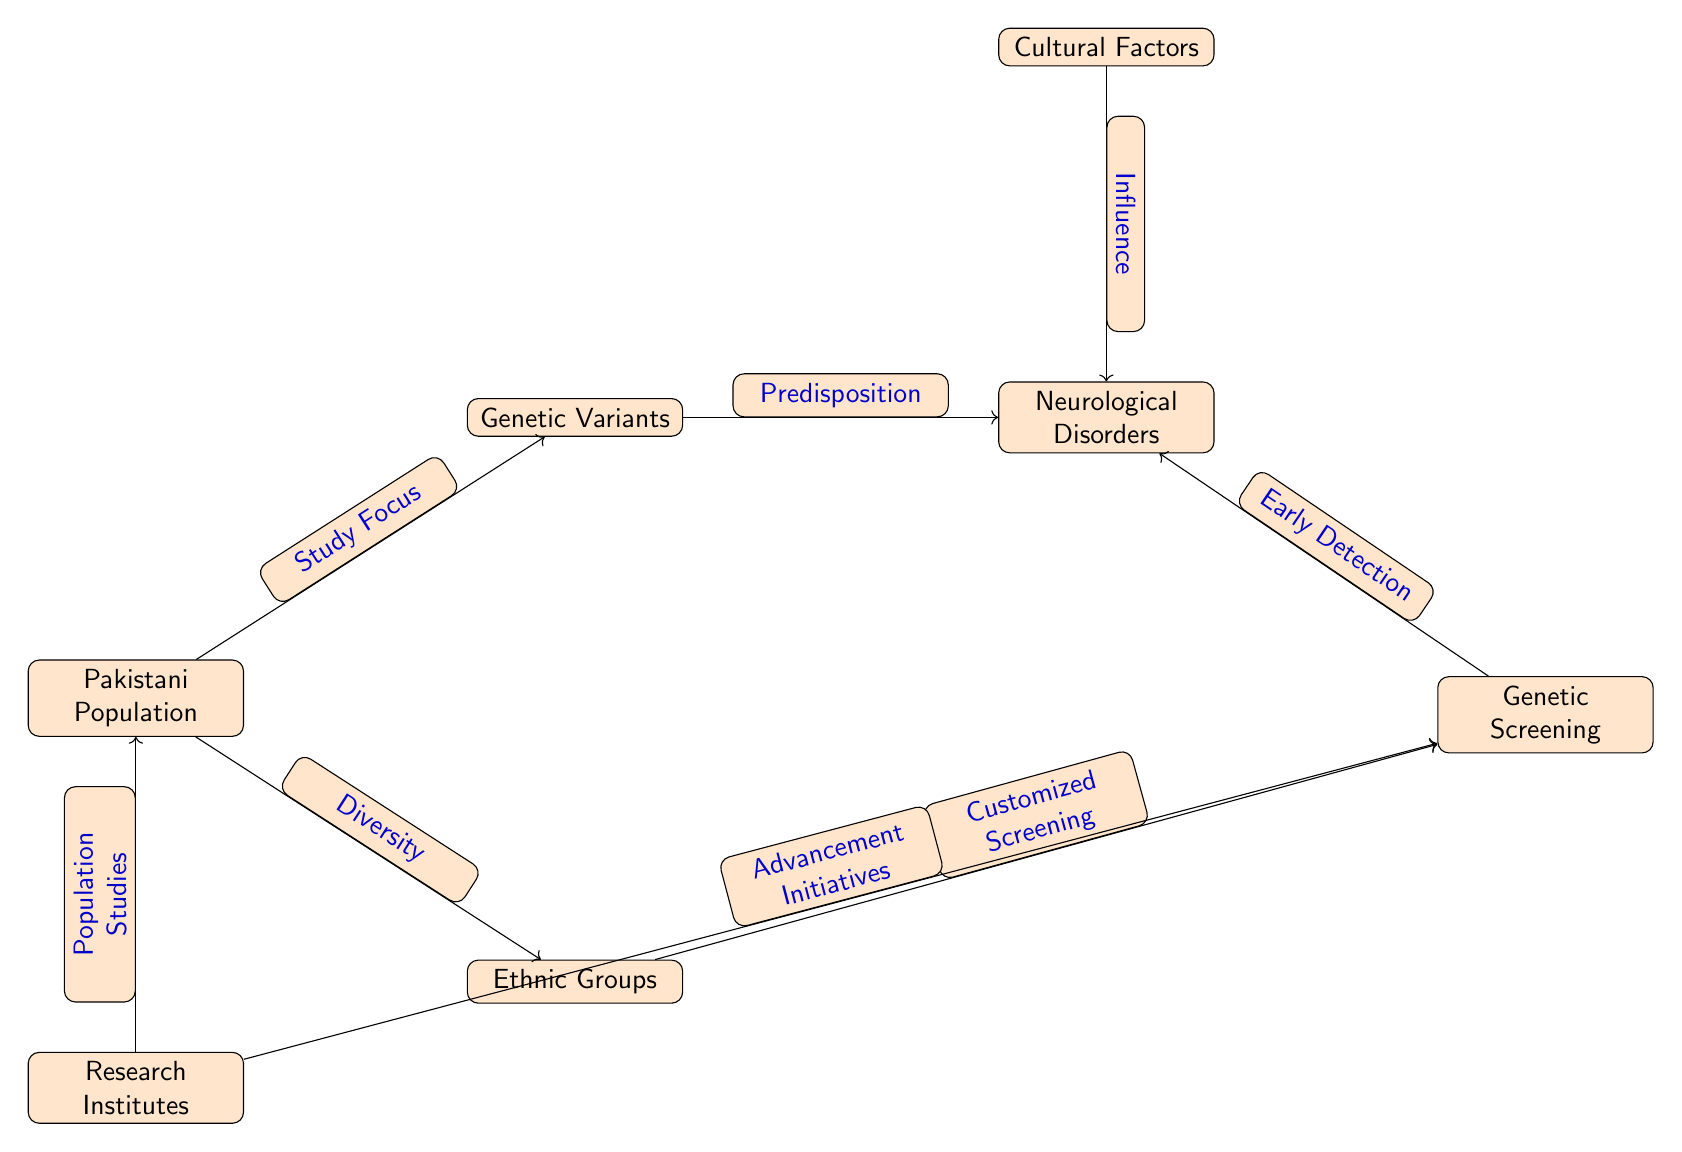What's the total number of nodes in the diagram? The diagram includes the following nodes: Genetic Variants, Neurological Disorders, Cultural Factors, Pakistani Population, Ethnic Groups, Genetic Screening, and Research Institutes. Counting these gives a total of 7 nodes.
Answer: 7 What is the relationship between Genetic Variants and Neurological Disorders? The diagram shows a directional edge from Genetic Variants to Neurological Disorders labeled as "Predisposition." This indicates that Genetic Variants contribute to the likelihood of Neurological Disorders.
Answer: Predisposition What influences Neurological Disorders according to the diagram? The diagram includes two influences on Neurological Disorders: one from Genetic Variants and another from Cultural Factors. Both labeled edges indicate different contributing factors.
Answer: Genetic Variants and Cultural Factors Which node represents different ethnic backgrounds within the Pakistani Population? The node labeled "Ethnic Groups" is placed below the Pakistani Population node and signifies diversity among ethnic backgrounds in the studies mentioned.
Answer: Ethnic Groups How is early detection of Neurological Disorders facilitated according to the diagram? The diagram shows that there is a directional edge from Genetic Screening to Neurological Disorders labeled "Early Detection," indicating that the screening process aids in the timely identification of disorders.
Answer: Early Detection What is said about the Pakistani Population in relation to Genetic Variants? According to the diagram, there is a directional edge from Pakistani Population to Genetic Variants labeled as "Study Focus," suggesting that the focus of the studies is on Genetic Variants within this population.
Answer: Study Focus How do Research Institutes contribute to the Genetic Screening process? The diagram portrays two edges coming from Research Institutes: one directing towards Genetic Screening labeled "Advancement Initiatives," and another to Pakistani Population labeled "Population Studies." This shows active involvement in both advancing Genetic Screening and studying the population.
Answer: Advancement Initiatives and Population Studies Which node is positioned directly above Neurological Disorders? The node directly above Neurological Disorders is labeled "Cultural Factors," showing its hierarchical placement in relation to the disorders.
Answer: Cultural Factors 